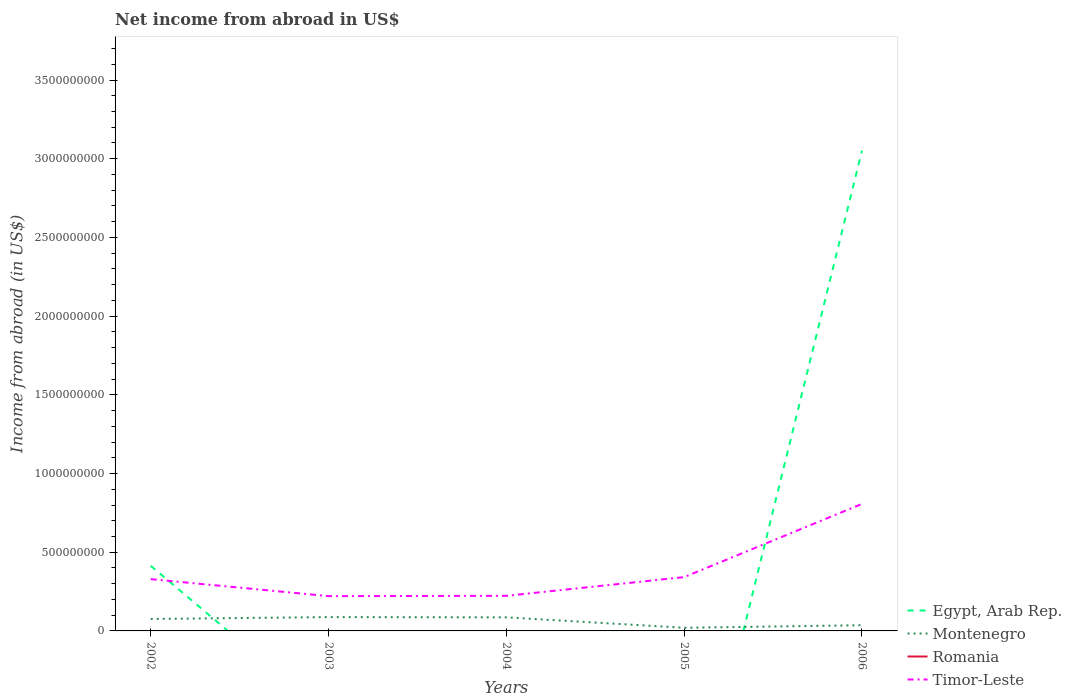Is the number of lines equal to the number of legend labels?
Make the answer very short. No. What is the total net income from abroad in Montenegro in the graph?
Your response must be concise. -1.62e+07. What is the difference between the highest and the second highest net income from abroad in Timor-Leste?
Your response must be concise. 5.86e+08. Is the net income from abroad in Timor-Leste strictly greater than the net income from abroad in Romania over the years?
Your response must be concise. No. Are the values on the major ticks of Y-axis written in scientific E-notation?
Your response must be concise. No. How are the legend labels stacked?
Provide a short and direct response. Vertical. What is the title of the graph?
Ensure brevity in your answer.  Net income from abroad in US$. Does "Uganda" appear as one of the legend labels in the graph?
Keep it short and to the point. No. What is the label or title of the X-axis?
Your answer should be compact. Years. What is the label or title of the Y-axis?
Your response must be concise. Income from abroad (in US$). What is the Income from abroad (in US$) of Egypt, Arab Rep. in 2002?
Your answer should be very brief. 4.14e+08. What is the Income from abroad (in US$) in Montenegro in 2002?
Ensure brevity in your answer.  7.59e+07. What is the Income from abroad (in US$) in Romania in 2002?
Provide a succinct answer. 0. What is the Income from abroad (in US$) of Timor-Leste in 2002?
Keep it short and to the point. 3.29e+08. What is the Income from abroad (in US$) of Montenegro in 2003?
Ensure brevity in your answer.  8.78e+07. What is the Income from abroad (in US$) of Romania in 2003?
Ensure brevity in your answer.  0. What is the Income from abroad (in US$) of Timor-Leste in 2003?
Give a very brief answer. 2.21e+08. What is the Income from abroad (in US$) of Montenegro in 2004?
Provide a succinct answer. 8.63e+07. What is the Income from abroad (in US$) in Romania in 2004?
Your answer should be very brief. 0. What is the Income from abroad (in US$) in Timor-Leste in 2004?
Your response must be concise. 2.23e+08. What is the Income from abroad (in US$) of Montenegro in 2005?
Provide a succinct answer. 2.00e+07. What is the Income from abroad (in US$) of Timor-Leste in 2005?
Make the answer very short. 3.42e+08. What is the Income from abroad (in US$) of Egypt, Arab Rep. in 2006?
Your response must be concise. 3.05e+09. What is the Income from abroad (in US$) in Montenegro in 2006?
Make the answer very short. 3.62e+07. What is the Income from abroad (in US$) in Timor-Leste in 2006?
Your response must be concise. 8.07e+08. Across all years, what is the maximum Income from abroad (in US$) of Egypt, Arab Rep.?
Provide a short and direct response. 3.05e+09. Across all years, what is the maximum Income from abroad (in US$) in Montenegro?
Your response must be concise. 8.78e+07. Across all years, what is the maximum Income from abroad (in US$) of Timor-Leste?
Your response must be concise. 8.07e+08. Across all years, what is the minimum Income from abroad (in US$) of Montenegro?
Ensure brevity in your answer.  2.00e+07. Across all years, what is the minimum Income from abroad (in US$) of Timor-Leste?
Your answer should be very brief. 2.21e+08. What is the total Income from abroad (in US$) of Egypt, Arab Rep. in the graph?
Provide a short and direct response. 3.47e+09. What is the total Income from abroad (in US$) in Montenegro in the graph?
Your answer should be compact. 3.06e+08. What is the total Income from abroad (in US$) of Romania in the graph?
Give a very brief answer. 0. What is the total Income from abroad (in US$) of Timor-Leste in the graph?
Ensure brevity in your answer.  1.92e+09. What is the difference between the Income from abroad (in US$) of Montenegro in 2002 and that in 2003?
Your answer should be compact. -1.19e+07. What is the difference between the Income from abroad (in US$) of Timor-Leste in 2002 and that in 2003?
Provide a short and direct response. 1.08e+08. What is the difference between the Income from abroad (in US$) in Montenegro in 2002 and that in 2004?
Your answer should be compact. -1.04e+07. What is the difference between the Income from abroad (in US$) in Timor-Leste in 2002 and that in 2004?
Offer a very short reply. 1.06e+08. What is the difference between the Income from abroad (in US$) in Montenegro in 2002 and that in 2005?
Provide a succinct answer. 5.59e+07. What is the difference between the Income from abroad (in US$) of Timor-Leste in 2002 and that in 2005?
Ensure brevity in your answer.  -1.30e+07. What is the difference between the Income from abroad (in US$) of Egypt, Arab Rep. in 2002 and that in 2006?
Offer a terse response. -2.64e+09. What is the difference between the Income from abroad (in US$) of Montenegro in 2002 and that in 2006?
Your response must be concise. 3.97e+07. What is the difference between the Income from abroad (in US$) in Timor-Leste in 2002 and that in 2006?
Your answer should be very brief. -4.78e+08. What is the difference between the Income from abroad (in US$) in Montenegro in 2003 and that in 2004?
Keep it short and to the point. 1.54e+06. What is the difference between the Income from abroad (in US$) in Montenegro in 2003 and that in 2005?
Provide a succinct answer. 6.78e+07. What is the difference between the Income from abroad (in US$) of Timor-Leste in 2003 and that in 2005?
Offer a very short reply. -1.21e+08. What is the difference between the Income from abroad (in US$) of Montenegro in 2003 and that in 2006?
Your response must be concise. 5.16e+07. What is the difference between the Income from abroad (in US$) of Timor-Leste in 2003 and that in 2006?
Make the answer very short. -5.86e+08. What is the difference between the Income from abroad (in US$) of Montenegro in 2004 and that in 2005?
Provide a short and direct response. 6.63e+07. What is the difference between the Income from abroad (in US$) of Timor-Leste in 2004 and that in 2005?
Your response must be concise. -1.19e+08. What is the difference between the Income from abroad (in US$) of Montenegro in 2004 and that in 2006?
Offer a terse response. 5.01e+07. What is the difference between the Income from abroad (in US$) in Timor-Leste in 2004 and that in 2006?
Offer a terse response. -5.84e+08. What is the difference between the Income from abroad (in US$) in Montenegro in 2005 and that in 2006?
Provide a short and direct response. -1.62e+07. What is the difference between the Income from abroad (in US$) in Timor-Leste in 2005 and that in 2006?
Your answer should be compact. -4.65e+08. What is the difference between the Income from abroad (in US$) of Egypt, Arab Rep. in 2002 and the Income from abroad (in US$) of Montenegro in 2003?
Offer a terse response. 3.26e+08. What is the difference between the Income from abroad (in US$) of Egypt, Arab Rep. in 2002 and the Income from abroad (in US$) of Timor-Leste in 2003?
Offer a terse response. 1.93e+08. What is the difference between the Income from abroad (in US$) of Montenegro in 2002 and the Income from abroad (in US$) of Timor-Leste in 2003?
Provide a short and direct response. -1.45e+08. What is the difference between the Income from abroad (in US$) in Egypt, Arab Rep. in 2002 and the Income from abroad (in US$) in Montenegro in 2004?
Give a very brief answer. 3.27e+08. What is the difference between the Income from abroad (in US$) in Egypt, Arab Rep. in 2002 and the Income from abroad (in US$) in Timor-Leste in 2004?
Your response must be concise. 1.91e+08. What is the difference between the Income from abroad (in US$) in Montenegro in 2002 and the Income from abroad (in US$) in Timor-Leste in 2004?
Offer a very short reply. -1.47e+08. What is the difference between the Income from abroad (in US$) in Egypt, Arab Rep. in 2002 and the Income from abroad (in US$) in Montenegro in 2005?
Keep it short and to the point. 3.94e+08. What is the difference between the Income from abroad (in US$) in Egypt, Arab Rep. in 2002 and the Income from abroad (in US$) in Timor-Leste in 2005?
Offer a terse response. 7.18e+07. What is the difference between the Income from abroad (in US$) of Montenegro in 2002 and the Income from abroad (in US$) of Timor-Leste in 2005?
Provide a short and direct response. -2.66e+08. What is the difference between the Income from abroad (in US$) of Egypt, Arab Rep. in 2002 and the Income from abroad (in US$) of Montenegro in 2006?
Your answer should be compact. 3.78e+08. What is the difference between the Income from abroad (in US$) in Egypt, Arab Rep. in 2002 and the Income from abroad (in US$) in Timor-Leste in 2006?
Your answer should be very brief. -3.93e+08. What is the difference between the Income from abroad (in US$) of Montenegro in 2002 and the Income from abroad (in US$) of Timor-Leste in 2006?
Your answer should be compact. -7.31e+08. What is the difference between the Income from abroad (in US$) in Montenegro in 2003 and the Income from abroad (in US$) in Timor-Leste in 2004?
Make the answer very short. -1.35e+08. What is the difference between the Income from abroad (in US$) in Montenegro in 2003 and the Income from abroad (in US$) in Timor-Leste in 2005?
Give a very brief answer. -2.54e+08. What is the difference between the Income from abroad (in US$) in Montenegro in 2003 and the Income from abroad (in US$) in Timor-Leste in 2006?
Provide a succinct answer. -7.19e+08. What is the difference between the Income from abroad (in US$) of Montenegro in 2004 and the Income from abroad (in US$) of Timor-Leste in 2005?
Give a very brief answer. -2.56e+08. What is the difference between the Income from abroad (in US$) in Montenegro in 2004 and the Income from abroad (in US$) in Timor-Leste in 2006?
Your response must be concise. -7.21e+08. What is the difference between the Income from abroad (in US$) in Montenegro in 2005 and the Income from abroad (in US$) in Timor-Leste in 2006?
Offer a very short reply. -7.87e+08. What is the average Income from abroad (in US$) in Egypt, Arab Rep. per year?
Offer a terse response. 6.93e+08. What is the average Income from abroad (in US$) in Montenegro per year?
Your answer should be compact. 6.13e+07. What is the average Income from abroad (in US$) in Romania per year?
Ensure brevity in your answer.  0. What is the average Income from abroad (in US$) of Timor-Leste per year?
Make the answer very short. 3.84e+08. In the year 2002, what is the difference between the Income from abroad (in US$) of Egypt, Arab Rep. and Income from abroad (in US$) of Montenegro?
Provide a succinct answer. 3.38e+08. In the year 2002, what is the difference between the Income from abroad (in US$) in Egypt, Arab Rep. and Income from abroad (in US$) in Timor-Leste?
Ensure brevity in your answer.  8.48e+07. In the year 2002, what is the difference between the Income from abroad (in US$) in Montenegro and Income from abroad (in US$) in Timor-Leste?
Keep it short and to the point. -2.53e+08. In the year 2003, what is the difference between the Income from abroad (in US$) in Montenegro and Income from abroad (in US$) in Timor-Leste?
Your response must be concise. -1.33e+08. In the year 2004, what is the difference between the Income from abroad (in US$) of Montenegro and Income from abroad (in US$) of Timor-Leste?
Ensure brevity in your answer.  -1.37e+08. In the year 2005, what is the difference between the Income from abroad (in US$) of Montenegro and Income from abroad (in US$) of Timor-Leste?
Your answer should be compact. -3.22e+08. In the year 2006, what is the difference between the Income from abroad (in US$) of Egypt, Arab Rep. and Income from abroad (in US$) of Montenegro?
Offer a terse response. 3.02e+09. In the year 2006, what is the difference between the Income from abroad (in US$) in Egypt, Arab Rep. and Income from abroad (in US$) in Timor-Leste?
Give a very brief answer. 2.24e+09. In the year 2006, what is the difference between the Income from abroad (in US$) in Montenegro and Income from abroad (in US$) in Timor-Leste?
Give a very brief answer. -7.71e+08. What is the ratio of the Income from abroad (in US$) of Montenegro in 2002 to that in 2003?
Provide a short and direct response. 0.86. What is the ratio of the Income from abroad (in US$) in Timor-Leste in 2002 to that in 2003?
Provide a short and direct response. 1.49. What is the ratio of the Income from abroad (in US$) of Montenegro in 2002 to that in 2004?
Provide a short and direct response. 0.88. What is the ratio of the Income from abroad (in US$) in Timor-Leste in 2002 to that in 2004?
Provide a succinct answer. 1.48. What is the ratio of the Income from abroad (in US$) of Montenegro in 2002 to that in 2005?
Provide a short and direct response. 3.79. What is the ratio of the Income from abroad (in US$) of Egypt, Arab Rep. in 2002 to that in 2006?
Offer a terse response. 0.14. What is the ratio of the Income from abroad (in US$) of Montenegro in 2002 to that in 2006?
Your answer should be compact. 2.09. What is the ratio of the Income from abroad (in US$) in Timor-Leste in 2002 to that in 2006?
Your response must be concise. 0.41. What is the ratio of the Income from abroad (in US$) in Montenegro in 2003 to that in 2004?
Ensure brevity in your answer.  1.02. What is the ratio of the Income from abroad (in US$) of Montenegro in 2003 to that in 2005?
Offer a very short reply. 4.39. What is the ratio of the Income from abroad (in US$) of Timor-Leste in 2003 to that in 2005?
Offer a terse response. 0.65. What is the ratio of the Income from abroad (in US$) in Montenegro in 2003 to that in 2006?
Make the answer very short. 2.42. What is the ratio of the Income from abroad (in US$) of Timor-Leste in 2003 to that in 2006?
Provide a succinct answer. 0.27. What is the ratio of the Income from abroad (in US$) of Montenegro in 2004 to that in 2005?
Offer a very short reply. 4.31. What is the ratio of the Income from abroad (in US$) in Timor-Leste in 2004 to that in 2005?
Make the answer very short. 0.65. What is the ratio of the Income from abroad (in US$) of Montenegro in 2004 to that in 2006?
Offer a terse response. 2.38. What is the ratio of the Income from abroad (in US$) in Timor-Leste in 2004 to that in 2006?
Your response must be concise. 0.28. What is the ratio of the Income from abroad (in US$) of Montenegro in 2005 to that in 2006?
Your answer should be compact. 0.55. What is the ratio of the Income from abroad (in US$) of Timor-Leste in 2005 to that in 2006?
Your response must be concise. 0.42. What is the difference between the highest and the second highest Income from abroad (in US$) in Montenegro?
Your answer should be compact. 1.54e+06. What is the difference between the highest and the second highest Income from abroad (in US$) of Timor-Leste?
Offer a terse response. 4.65e+08. What is the difference between the highest and the lowest Income from abroad (in US$) in Egypt, Arab Rep.?
Your answer should be compact. 3.05e+09. What is the difference between the highest and the lowest Income from abroad (in US$) in Montenegro?
Your answer should be very brief. 6.78e+07. What is the difference between the highest and the lowest Income from abroad (in US$) in Timor-Leste?
Your answer should be very brief. 5.86e+08. 